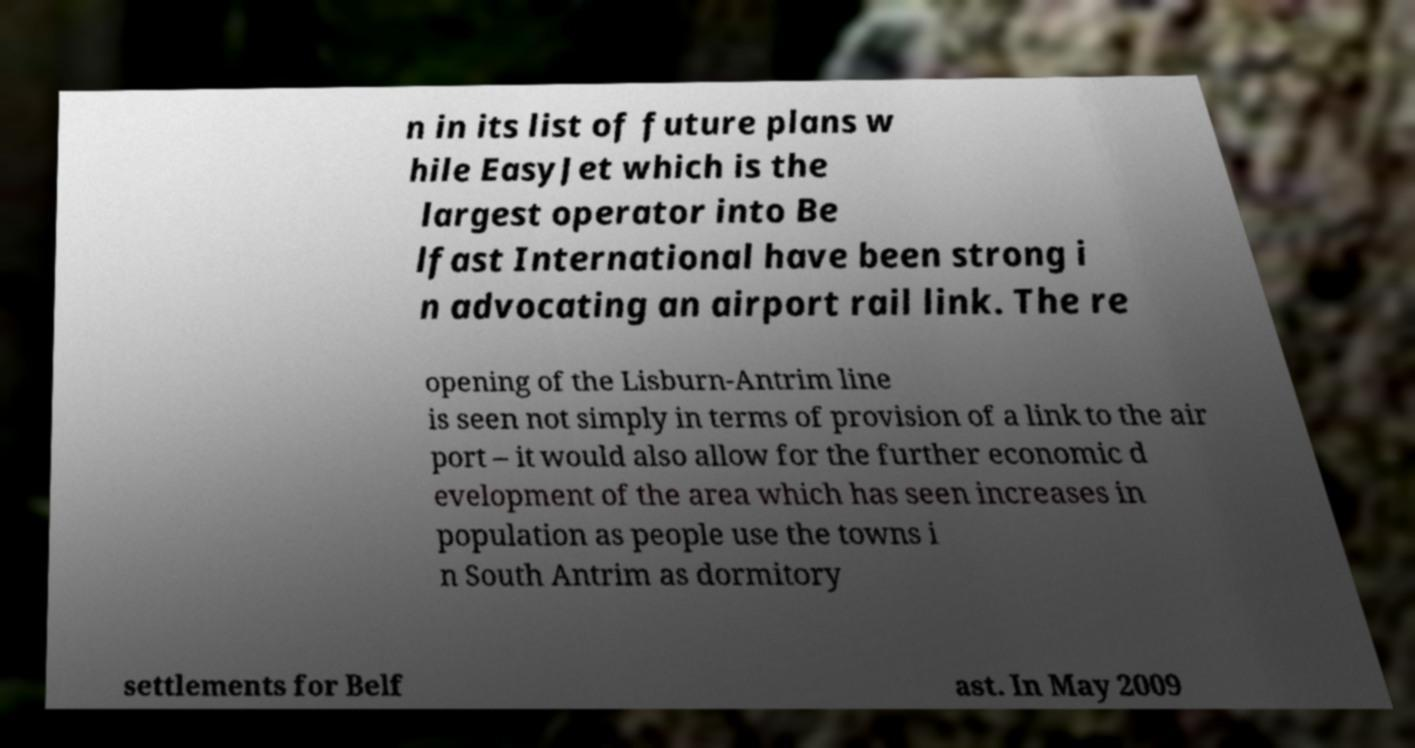Could you assist in decoding the text presented in this image and type it out clearly? n in its list of future plans w hile EasyJet which is the largest operator into Be lfast International have been strong i n advocating an airport rail link. The re opening of the Lisburn-Antrim line is seen not simply in terms of provision of a link to the air port – it would also allow for the further economic d evelopment of the area which has seen increases in population as people use the towns i n South Antrim as dormitory settlements for Belf ast. In May 2009 